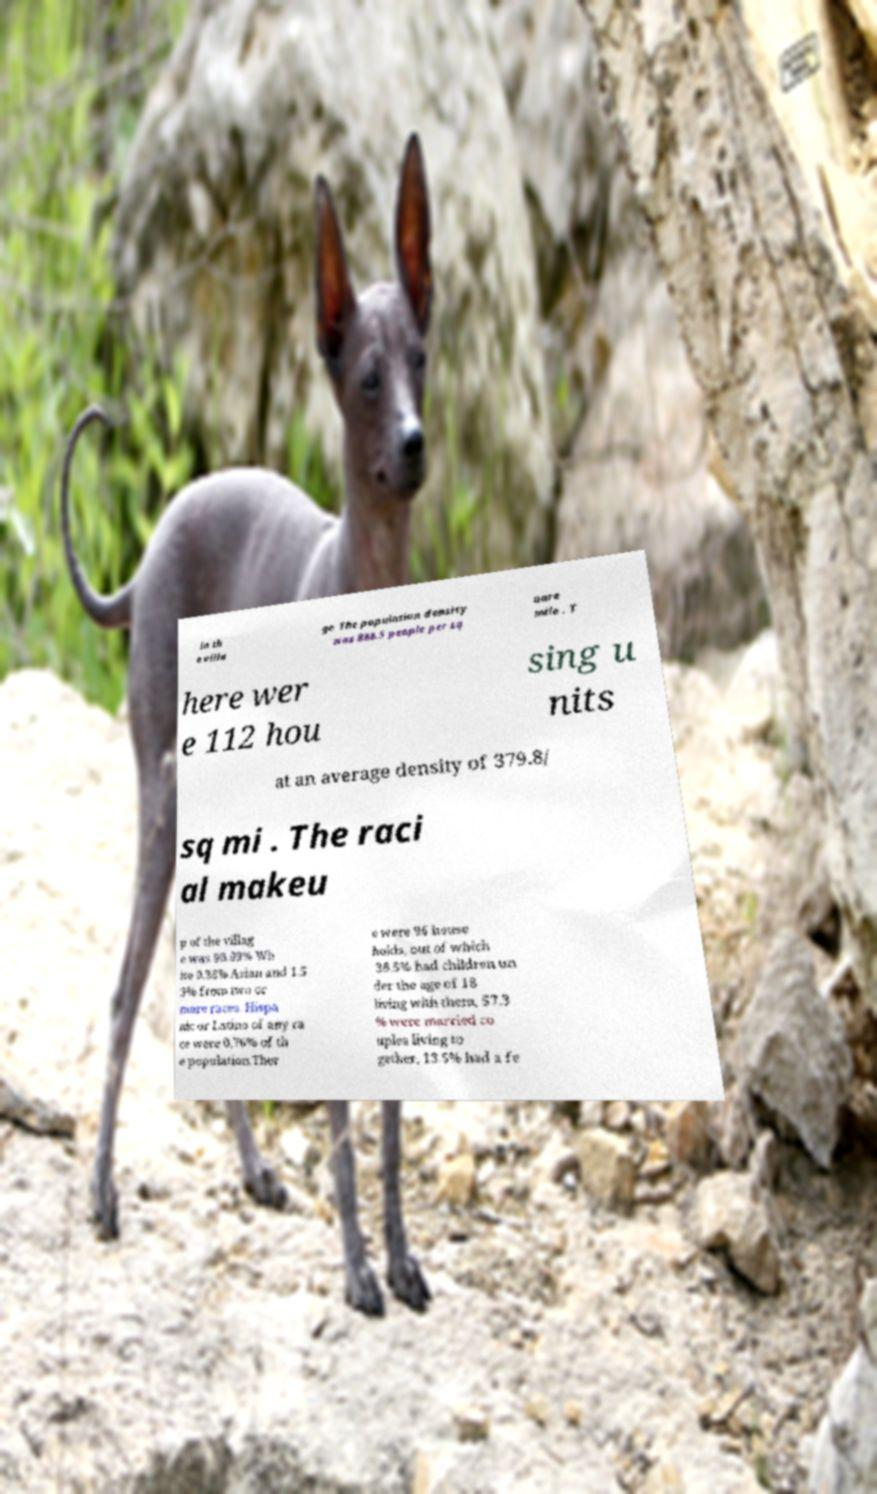I need the written content from this picture converted into text. Can you do that? in th e villa ge. The population density was 888.5 people per sq uare mile . T here wer e 112 hou sing u nits at an average density of 379.8/ sq mi . The raci al makeu p of the villag e was 98.09% Wh ite 0.38% Asian and 1.5 3% from two or more races. Hispa nic or Latino of any ra ce were 0.76% of th e population.Ther e were 96 house holds, out of which 38.5% had children un der the age of 18 living with them, 57.3 % were married co uples living to gether, 13.5% had a fe 